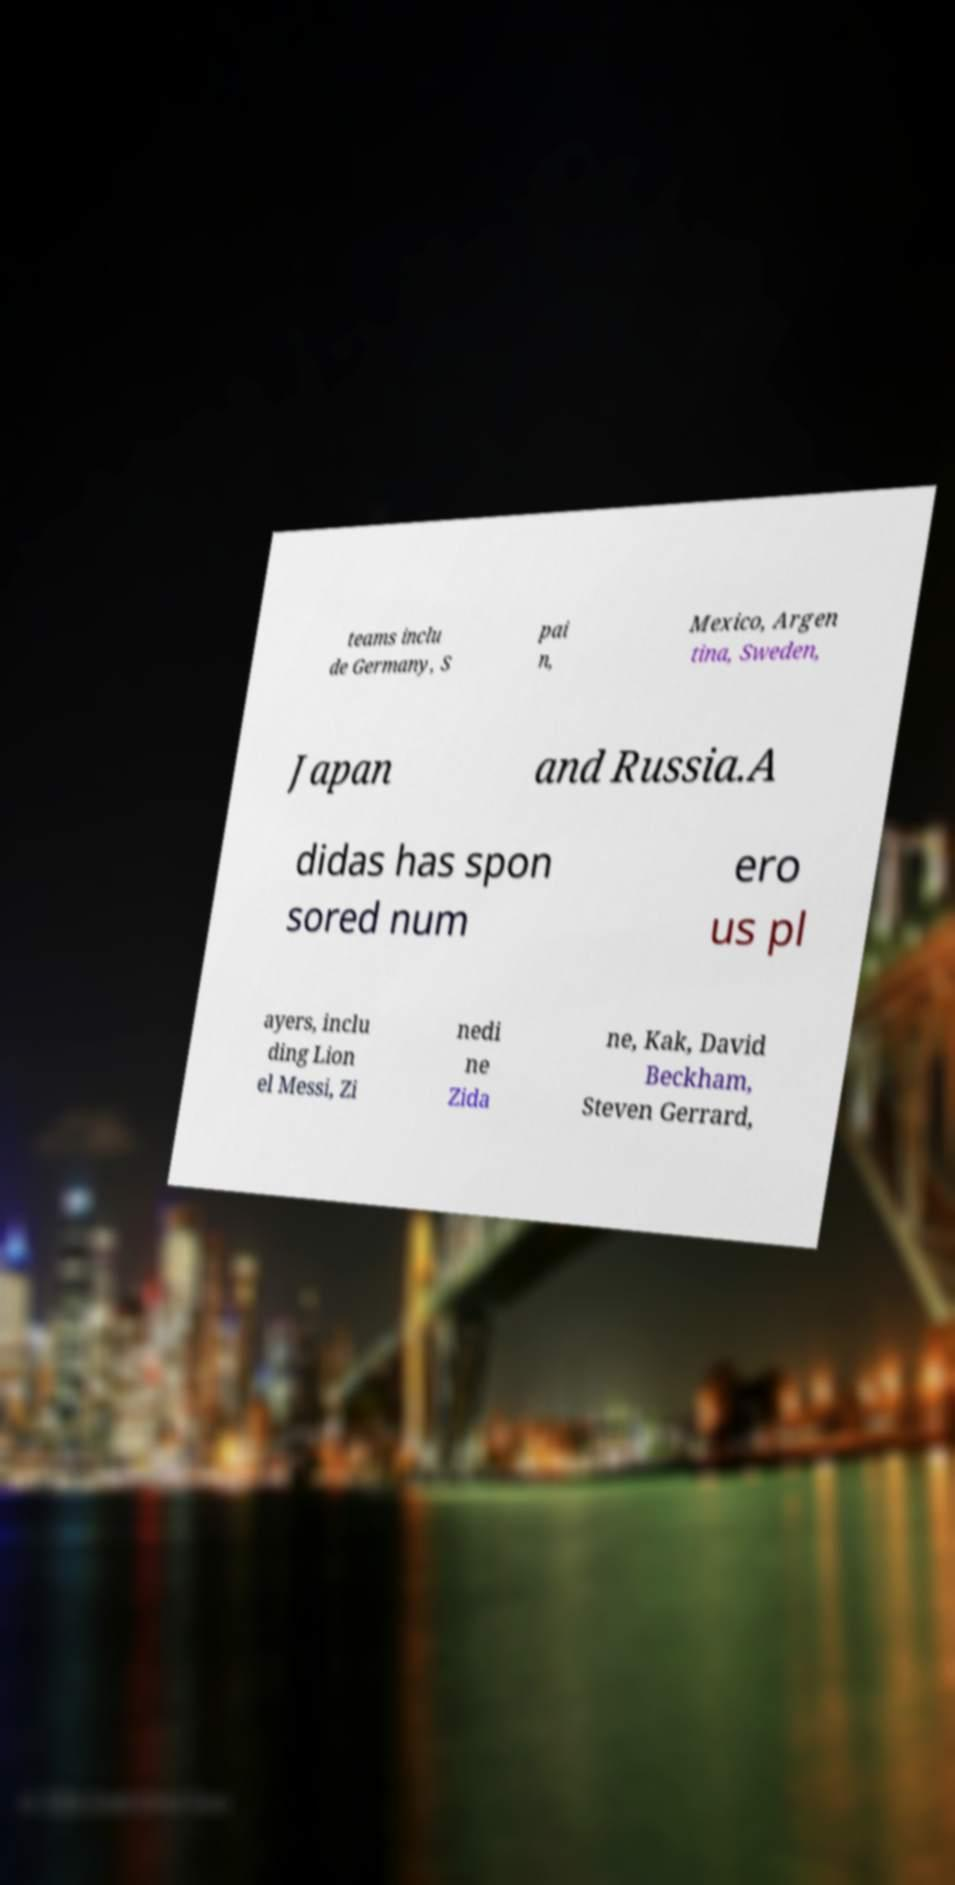What messages or text are displayed in this image? I need them in a readable, typed format. teams inclu de Germany, S pai n, Mexico, Argen tina, Sweden, Japan and Russia.A didas has spon sored num ero us pl ayers, inclu ding Lion el Messi, Zi nedi ne Zida ne, Kak, David Beckham, Steven Gerrard, 